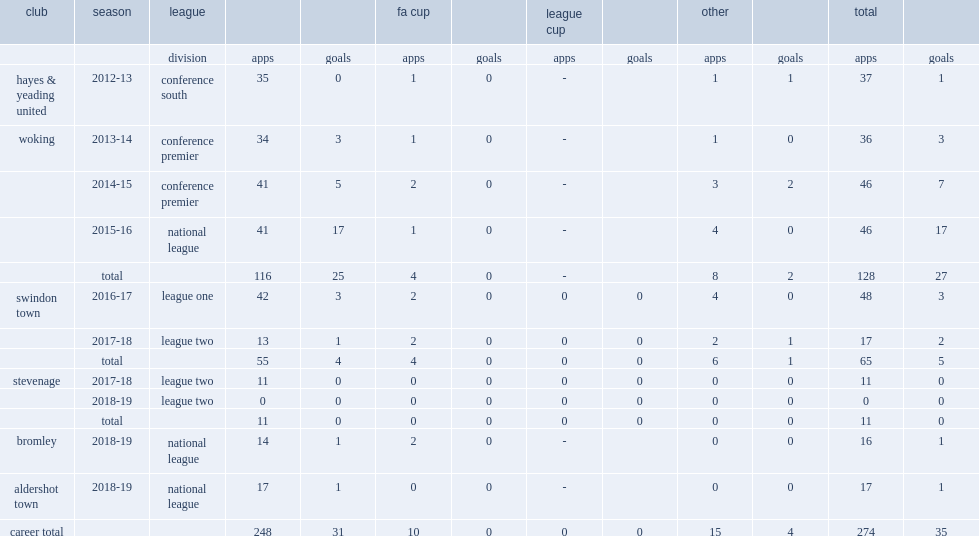Which club did goddard play for in 2013-14? Woking. 